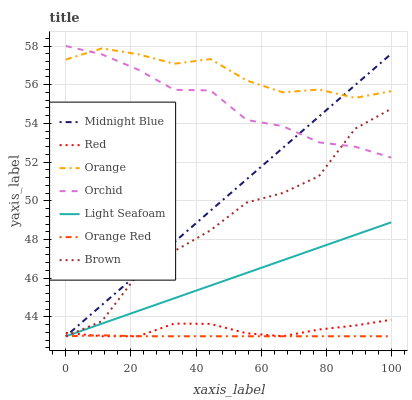Does Orange Red have the minimum area under the curve?
Answer yes or no. Yes. Does Orange have the maximum area under the curve?
Answer yes or no. Yes. Does Midnight Blue have the minimum area under the curve?
Answer yes or no. No. Does Midnight Blue have the maximum area under the curve?
Answer yes or no. No. Is Midnight Blue the smoothest?
Answer yes or no. Yes. Is Brown the roughest?
Answer yes or no. Yes. Is Orange the smoothest?
Answer yes or no. No. Is Orange the roughest?
Answer yes or no. No. Does Brown have the lowest value?
Answer yes or no. Yes. Does Orange have the lowest value?
Answer yes or no. No. Does Orchid have the highest value?
Answer yes or no. Yes. Does Midnight Blue have the highest value?
Answer yes or no. No. Is Red less than Orchid?
Answer yes or no. Yes. Is Orange greater than Orange Red?
Answer yes or no. Yes. Does Midnight Blue intersect Orange Red?
Answer yes or no. Yes. Is Midnight Blue less than Orange Red?
Answer yes or no. No. Is Midnight Blue greater than Orange Red?
Answer yes or no. No. Does Red intersect Orchid?
Answer yes or no. No. 